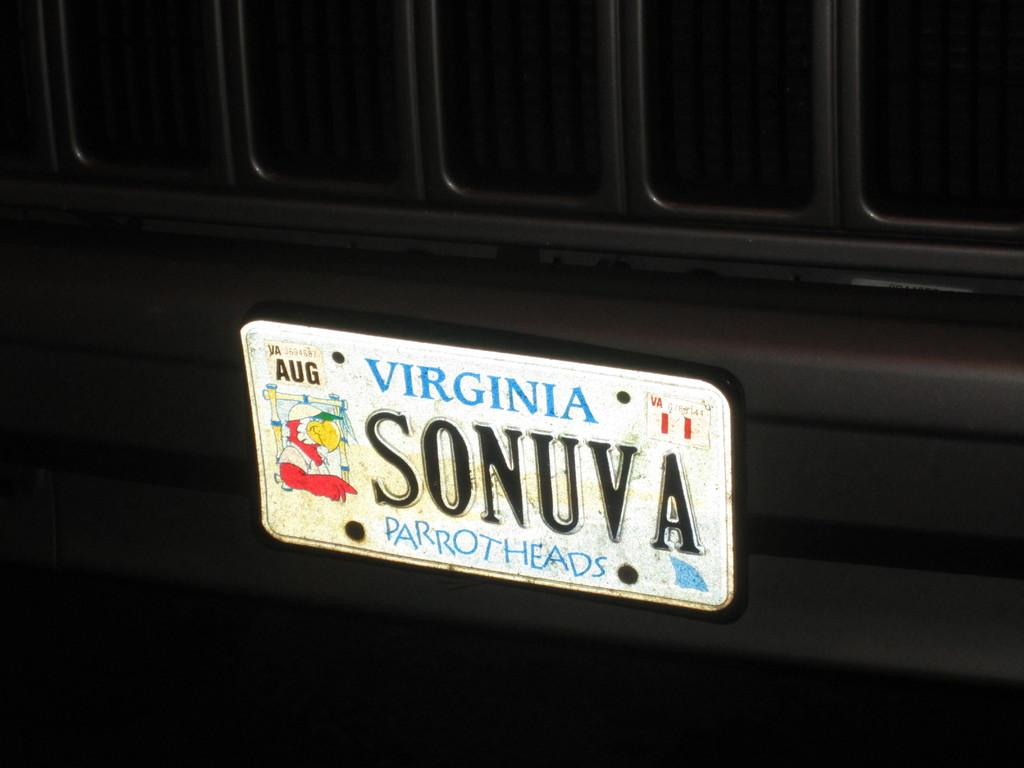<image>
Create a compact narrative representing the image presented. A black vehicle has a license plate that says Virginia Parrot Heads. 